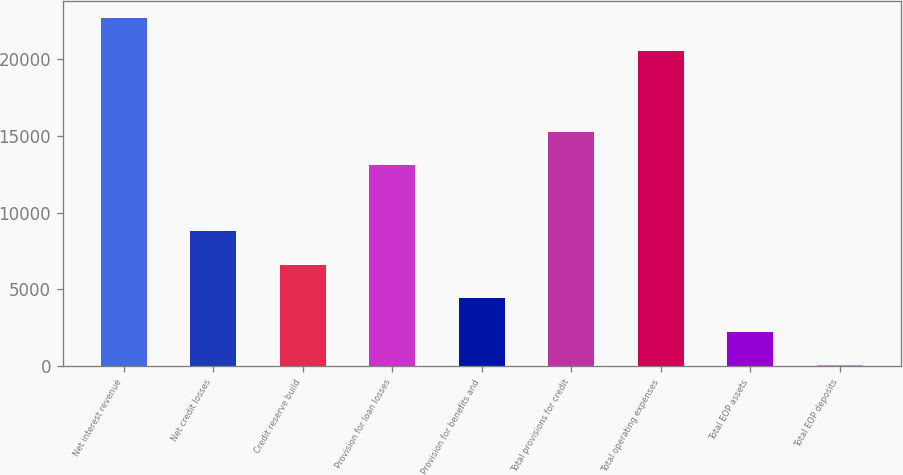Convert chart. <chart><loc_0><loc_0><loc_500><loc_500><bar_chart><fcel>Net interest revenue<fcel>Net credit losses<fcel>Credit reserve build<fcel>Provision for loan losses<fcel>Provision for benefits and<fcel>Total provisions for credit<fcel>Total operating expenses<fcel>Total EOP assets<fcel>Total EOP deposits<nl><fcel>22658.8<fcel>8766.2<fcel>6594.4<fcel>13066<fcel>4422.6<fcel>15237.8<fcel>20487<fcel>2250.8<fcel>79<nl></chart> 